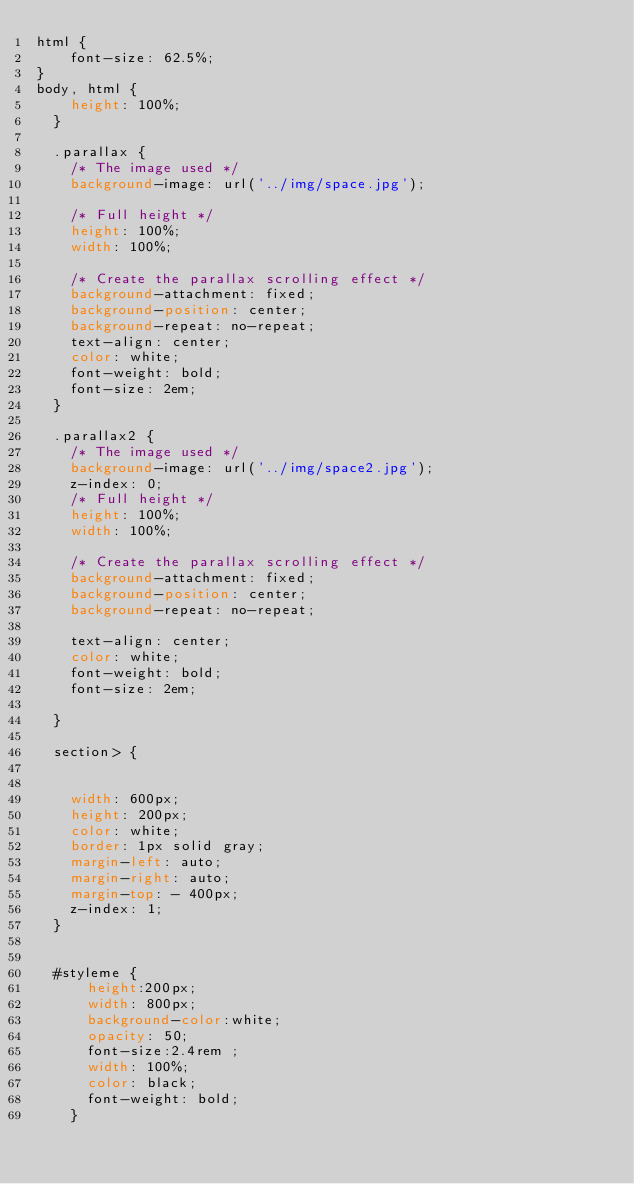<code> <loc_0><loc_0><loc_500><loc_500><_CSS_>html {
    font-size: 62.5%;
}
body, html {
    height: 100%;
  }
  
  .parallax {
    /* The image used */
    background-image: url('../img/space.jpg');
  
    /* Full height */
    height: 100%; 
    width: 100%;
  
    /* Create the parallax scrolling effect */
    background-attachment: fixed;
    background-position: center;
    background-repeat: no-repeat;
    text-align: center;
    color: white;
    font-weight: bold;
    font-size: 2em;
  }

  .parallax2 {
    /* The image used */
    background-image: url('../img/space2.jpg');
    z-index: 0;
    /* Full height */
    height: 100%; 
    width: 100%;
  
    /* Create the parallax scrolling effect */
    background-attachment: fixed;
    background-position: center;
    background-repeat: no-repeat;

    text-align: center;
    color: white;
    font-weight: bold;
    font-size: 2em;
    
  }

  section> {

   
    width: 600px;
    height: 200px;
    color: white;
    border: 1px solid gray;
    margin-left: auto;
    margin-right: auto;
    margin-top: - 400px;
    z-index: 1;
  }
  

  #styleme {
      height:200px;
      width: 800px;
      background-color:white;
      opacity: 50;
      font-size:2.4rem ;
      width: 100%;
      color: black;
      font-weight: bold;
    }</code> 